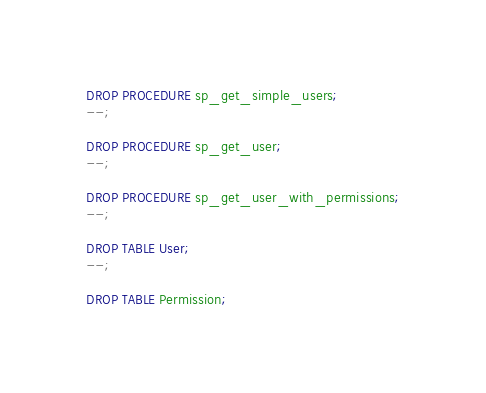Convert code to text. <code><loc_0><loc_0><loc_500><loc_500><_SQL_>DROP PROCEDURE sp_get_simple_users;
--;

DROP PROCEDURE sp_get_user;
--;

DROP PROCEDURE sp_get_user_with_permissions;
--;

DROP TABLE User;
--;

DROP TABLE Permission;</code> 